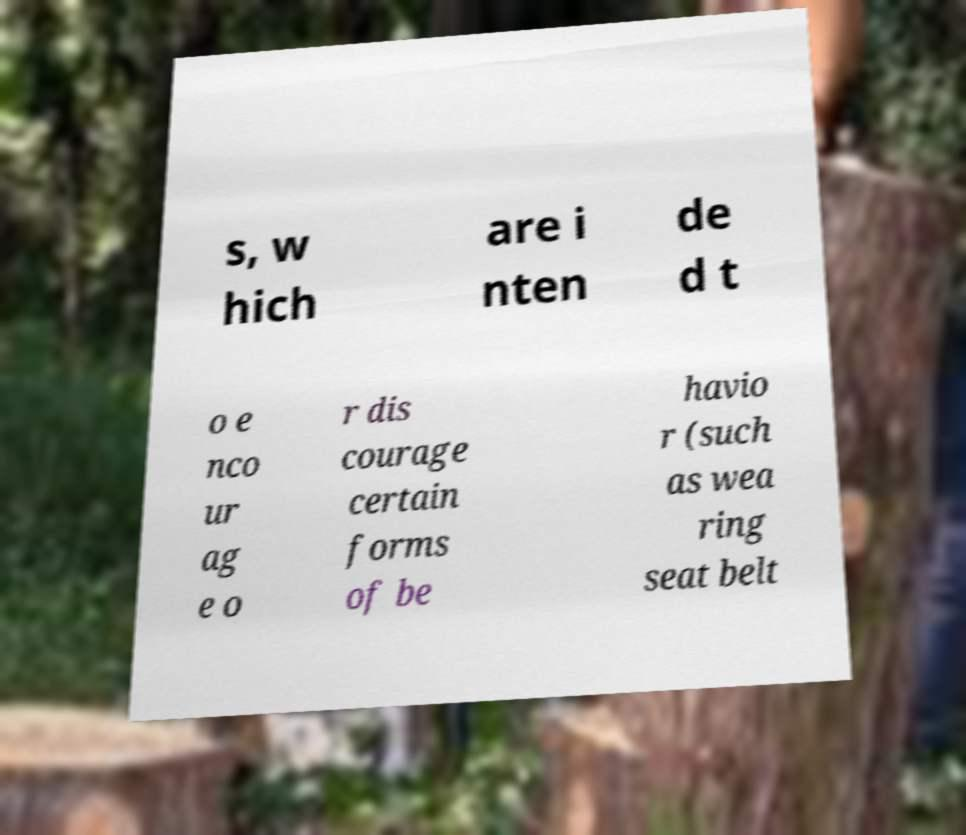Could you extract and type out the text from this image? s, w hich are i nten de d t o e nco ur ag e o r dis courage certain forms of be havio r (such as wea ring seat belt 